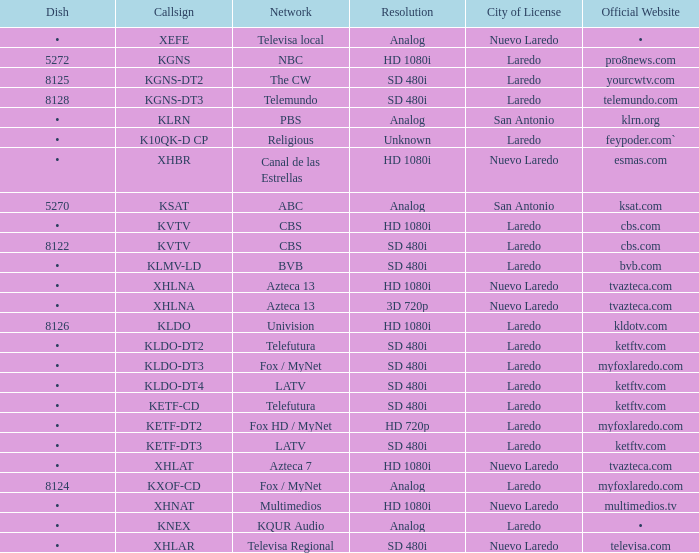Name the resolution for ketftv.com and callsign of kldo-dt2 SD 480i. 